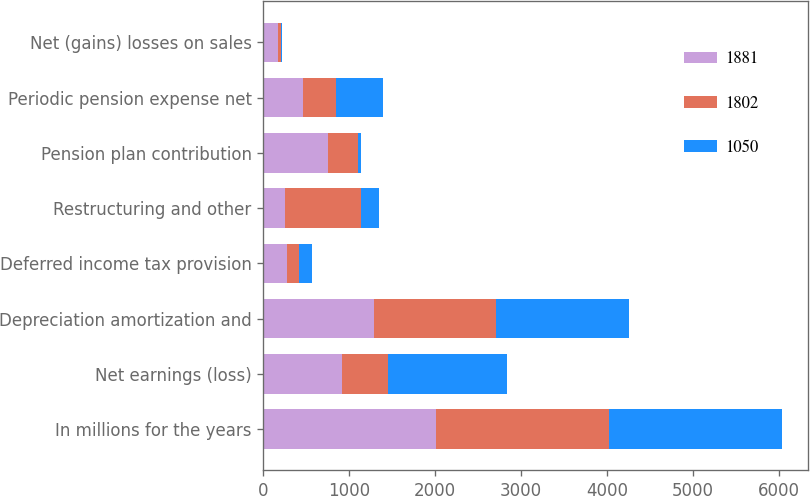<chart> <loc_0><loc_0><loc_500><loc_500><stacked_bar_chart><ecel><fcel>In millions for the years<fcel>Net earnings (loss)<fcel>Depreciation amortization and<fcel>Deferred income tax provision<fcel>Restructuring and other<fcel>Pension plan contribution<fcel>Periodic pension expense net<fcel>Net (gains) losses on sales<nl><fcel>1881<fcel>2015<fcel>917<fcel>1294<fcel>281<fcel>252<fcel>750<fcel>461<fcel>174<nl><fcel>1802<fcel>2014<fcel>536<fcel>1414<fcel>135<fcel>881<fcel>353<fcel>387<fcel>38<nl><fcel>1050<fcel>2013<fcel>1378<fcel>1547<fcel>146<fcel>210<fcel>31<fcel>545<fcel>3<nl></chart> 